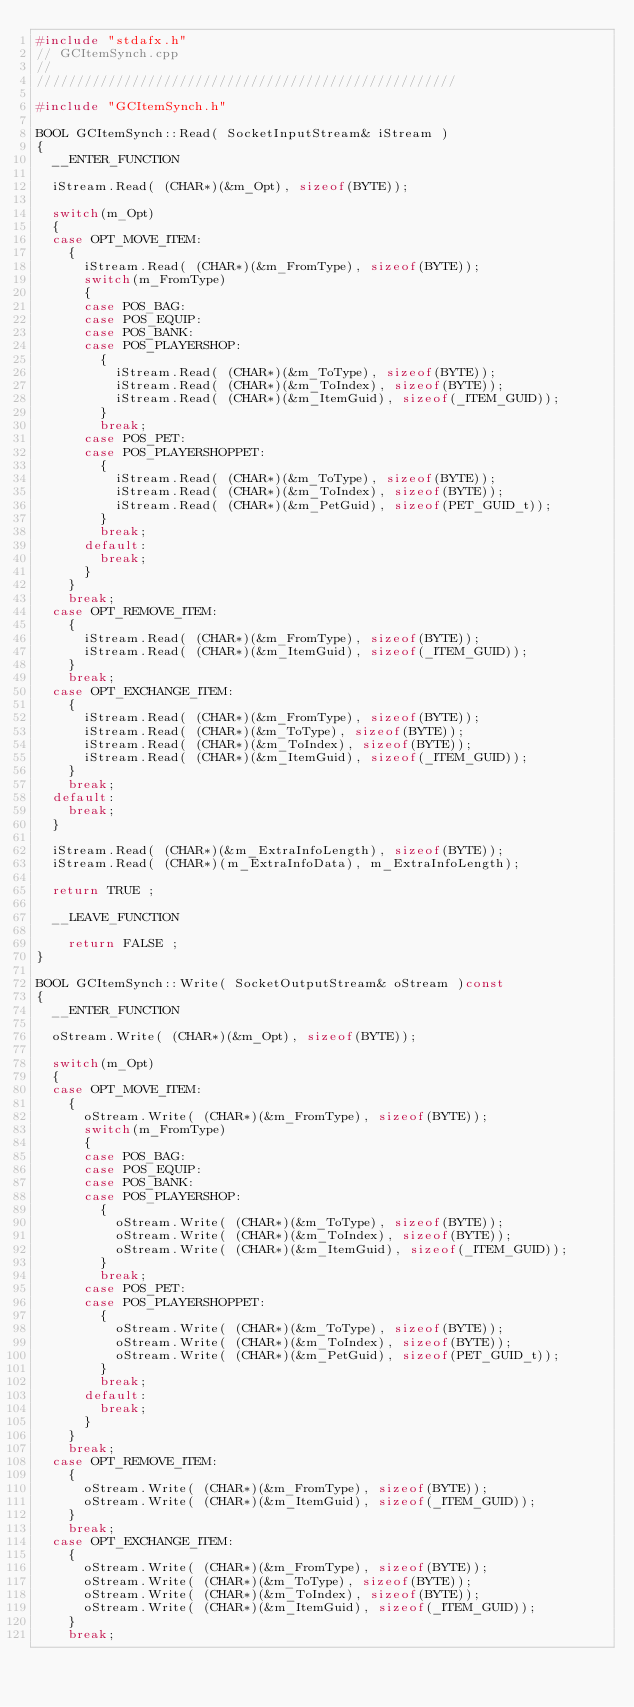<code> <loc_0><loc_0><loc_500><loc_500><_C++_>#include "stdafx.h"
// GCItemSynch.cpp
// 
/////////////////////////////////////////////////////

#include "GCItemSynch.h"

BOOL GCItemSynch::Read( SocketInputStream& iStream ) 
{
	__ENTER_FUNCTION

	iStream.Read( (CHAR*)(&m_Opt), sizeof(BYTE));

	switch(m_Opt)
	{
	case OPT_MOVE_ITEM:
		{
			iStream.Read( (CHAR*)(&m_FromType), sizeof(BYTE));
			switch(m_FromType)
			{
			case POS_BAG:
			case POS_EQUIP:
			case POS_BANK:
			case POS_PLAYERSHOP:
				{
					iStream.Read( (CHAR*)(&m_ToType), sizeof(BYTE));
					iStream.Read( (CHAR*)(&m_ToIndex), sizeof(BYTE));
					iStream.Read( (CHAR*)(&m_ItemGuid), sizeof(_ITEM_GUID));
				}
				break;
			case POS_PET:
			case POS_PLAYERSHOPPET:
				{
					iStream.Read( (CHAR*)(&m_ToType), sizeof(BYTE));
					iStream.Read( (CHAR*)(&m_ToIndex), sizeof(BYTE));
					iStream.Read( (CHAR*)(&m_PetGuid), sizeof(PET_GUID_t));
				}
				break;
			default:
				break;
			}
		}
		break;
	case OPT_REMOVE_ITEM:
		{
			iStream.Read( (CHAR*)(&m_FromType), sizeof(BYTE));
			iStream.Read( (CHAR*)(&m_ItemGuid), sizeof(_ITEM_GUID));
		}
		break;
	case OPT_EXCHANGE_ITEM:
		{
			iStream.Read( (CHAR*)(&m_FromType), sizeof(BYTE));
			iStream.Read( (CHAR*)(&m_ToType), sizeof(BYTE));
			iStream.Read( (CHAR*)(&m_ToIndex), sizeof(BYTE));
			iStream.Read( (CHAR*)(&m_ItemGuid), sizeof(_ITEM_GUID));
		}
		break;
	default:
		break;
	}

	iStream.Read( (CHAR*)(&m_ExtraInfoLength), sizeof(BYTE));
	iStream.Read( (CHAR*)(m_ExtraInfoData), m_ExtraInfoLength);

	return TRUE ;

	__LEAVE_FUNCTION

		return FALSE ;
}

BOOL GCItemSynch::Write( SocketOutputStream& oStream )const
{
	__ENTER_FUNCTION

	oStream.Write( (CHAR*)(&m_Opt), sizeof(BYTE));

	switch(m_Opt)
	{
	case OPT_MOVE_ITEM:
		{
			oStream.Write( (CHAR*)(&m_FromType), sizeof(BYTE));
			switch(m_FromType)
			{
			case POS_BAG:
			case POS_EQUIP:
			case POS_BANK:
			case POS_PLAYERSHOP:
				{
					oStream.Write( (CHAR*)(&m_ToType), sizeof(BYTE));
					oStream.Write( (CHAR*)(&m_ToIndex), sizeof(BYTE));
					oStream.Write( (CHAR*)(&m_ItemGuid), sizeof(_ITEM_GUID));
				}
				break;
			case POS_PET:
			case POS_PLAYERSHOPPET:
				{
					oStream.Write( (CHAR*)(&m_ToType), sizeof(BYTE));
					oStream.Write( (CHAR*)(&m_ToIndex), sizeof(BYTE));
					oStream.Write( (CHAR*)(&m_PetGuid), sizeof(PET_GUID_t));
				}
				break;
			default:
				break;
			}
		}
		break;
	case OPT_REMOVE_ITEM:
		{
			oStream.Write( (CHAR*)(&m_FromType), sizeof(BYTE));
			oStream.Write( (CHAR*)(&m_ItemGuid), sizeof(_ITEM_GUID));
		}
		break;
	case OPT_EXCHANGE_ITEM:
		{
			oStream.Write( (CHAR*)(&m_FromType), sizeof(BYTE));
			oStream.Write( (CHAR*)(&m_ToType), sizeof(BYTE));
			oStream.Write( (CHAR*)(&m_ToIndex), sizeof(BYTE));
			oStream.Write( (CHAR*)(&m_ItemGuid), sizeof(_ITEM_GUID));
		}
		break;
</code> 